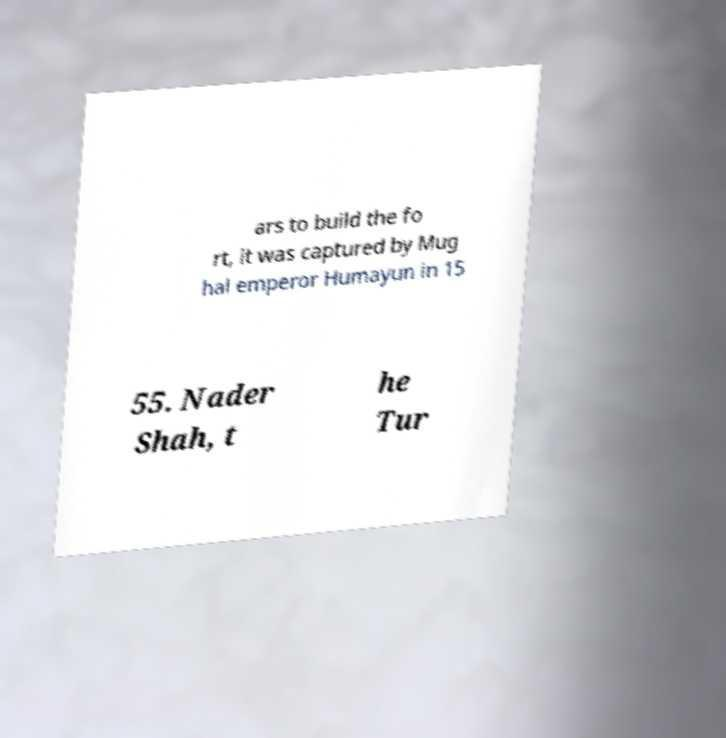Can you accurately transcribe the text from the provided image for me? ars to build the fo rt, it was captured by Mug hal emperor Humayun in 15 55. Nader Shah, t he Tur 